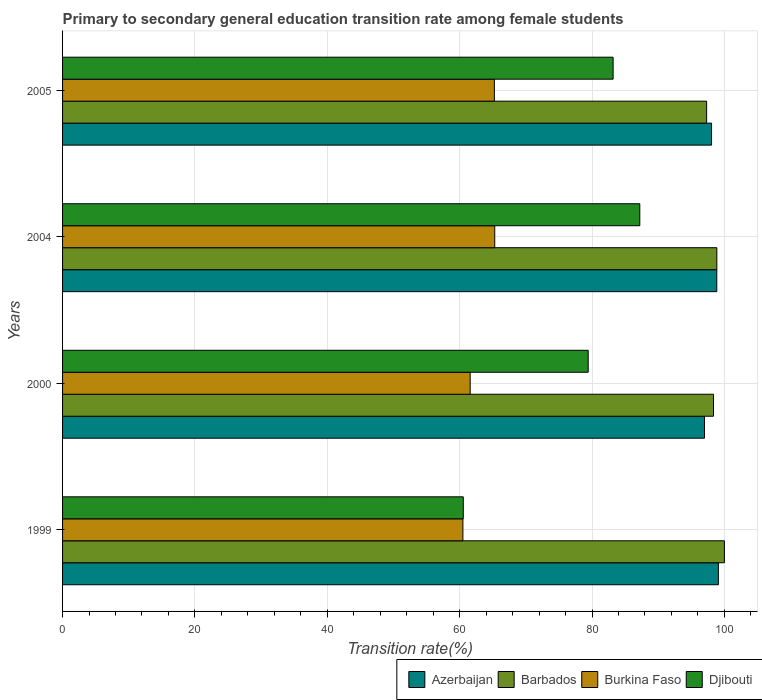How many different coloured bars are there?
Make the answer very short. 4. Are the number of bars per tick equal to the number of legend labels?
Make the answer very short. Yes. What is the transition rate in Azerbaijan in 2000?
Your answer should be compact. 96.99. Across all years, what is the maximum transition rate in Burkina Faso?
Make the answer very short. 65.3. Across all years, what is the minimum transition rate in Barbados?
Offer a terse response. 97.31. In which year was the transition rate in Azerbaijan maximum?
Make the answer very short. 1999. In which year was the transition rate in Burkina Faso minimum?
Provide a succinct answer. 1999. What is the total transition rate in Azerbaijan in the graph?
Your answer should be compact. 392.99. What is the difference between the transition rate in Barbados in 2000 and that in 2005?
Ensure brevity in your answer.  1.04. What is the difference between the transition rate in Azerbaijan in 2005 and the transition rate in Barbados in 2000?
Provide a short and direct response. -0.29. What is the average transition rate in Djibouti per year?
Keep it short and to the point. 77.59. In the year 2000, what is the difference between the transition rate in Djibouti and transition rate in Burkina Faso?
Your response must be concise. 17.83. In how many years, is the transition rate in Azerbaijan greater than 12 %?
Keep it short and to the point. 4. What is the ratio of the transition rate in Azerbaijan in 2004 to that in 2005?
Ensure brevity in your answer.  1.01. What is the difference between the highest and the second highest transition rate in Barbados?
Offer a terse response. 1.14. What is the difference between the highest and the lowest transition rate in Azerbaijan?
Provide a short and direct response. 2.1. In how many years, is the transition rate in Barbados greater than the average transition rate in Barbados taken over all years?
Keep it short and to the point. 2. Is the sum of the transition rate in Azerbaijan in 1999 and 2000 greater than the maximum transition rate in Djibouti across all years?
Your response must be concise. Yes. Is it the case that in every year, the sum of the transition rate in Barbados and transition rate in Azerbaijan is greater than the sum of transition rate in Burkina Faso and transition rate in Djibouti?
Offer a very short reply. Yes. What does the 1st bar from the top in 1999 represents?
Your answer should be very brief. Djibouti. What does the 2nd bar from the bottom in 2004 represents?
Provide a succinct answer. Barbados. Are all the bars in the graph horizontal?
Give a very brief answer. Yes. What is the difference between two consecutive major ticks on the X-axis?
Your response must be concise. 20. How are the legend labels stacked?
Provide a succinct answer. Horizontal. What is the title of the graph?
Your answer should be compact. Primary to secondary general education transition rate among female students. What is the label or title of the X-axis?
Offer a terse response. Transition rate(%). What is the Transition rate(%) of Azerbaijan in 1999?
Provide a short and direct response. 99.09. What is the Transition rate(%) of Burkina Faso in 1999?
Your answer should be very brief. 60.49. What is the Transition rate(%) of Djibouti in 1999?
Provide a succinct answer. 60.55. What is the Transition rate(%) of Azerbaijan in 2000?
Your answer should be very brief. 96.99. What is the Transition rate(%) of Barbados in 2000?
Your answer should be compact. 98.35. What is the Transition rate(%) in Burkina Faso in 2000?
Ensure brevity in your answer.  61.59. What is the Transition rate(%) of Djibouti in 2000?
Keep it short and to the point. 79.42. What is the Transition rate(%) of Azerbaijan in 2004?
Offer a very short reply. 98.85. What is the Transition rate(%) in Barbados in 2004?
Your response must be concise. 98.86. What is the Transition rate(%) in Burkina Faso in 2004?
Offer a very short reply. 65.3. What is the Transition rate(%) of Djibouti in 2004?
Provide a succinct answer. 87.22. What is the Transition rate(%) of Azerbaijan in 2005?
Ensure brevity in your answer.  98.06. What is the Transition rate(%) in Barbados in 2005?
Provide a succinct answer. 97.31. What is the Transition rate(%) of Burkina Faso in 2005?
Provide a succinct answer. 65.24. What is the Transition rate(%) of Djibouti in 2005?
Provide a succinct answer. 83.19. Across all years, what is the maximum Transition rate(%) in Azerbaijan?
Provide a short and direct response. 99.09. Across all years, what is the maximum Transition rate(%) of Burkina Faso?
Provide a short and direct response. 65.3. Across all years, what is the maximum Transition rate(%) in Djibouti?
Your response must be concise. 87.22. Across all years, what is the minimum Transition rate(%) in Azerbaijan?
Your answer should be compact. 96.99. Across all years, what is the minimum Transition rate(%) of Barbados?
Provide a short and direct response. 97.31. Across all years, what is the minimum Transition rate(%) of Burkina Faso?
Ensure brevity in your answer.  60.49. Across all years, what is the minimum Transition rate(%) of Djibouti?
Your answer should be very brief. 60.55. What is the total Transition rate(%) of Azerbaijan in the graph?
Keep it short and to the point. 392.99. What is the total Transition rate(%) in Barbados in the graph?
Offer a terse response. 394.52. What is the total Transition rate(%) of Burkina Faso in the graph?
Ensure brevity in your answer.  252.62. What is the total Transition rate(%) of Djibouti in the graph?
Make the answer very short. 310.37. What is the difference between the Transition rate(%) of Azerbaijan in 1999 and that in 2000?
Keep it short and to the point. 2.1. What is the difference between the Transition rate(%) of Barbados in 1999 and that in 2000?
Your answer should be compact. 1.65. What is the difference between the Transition rate(%) in Burkina Faso in 1999 and that in 2000?
Offer a very short reply. -1.1. What is the difference between the Transition rate(%) in Djibouti in 1999 and that in 2000?
Provide a short and direct response. -18.87. What is the difference between the Transition rate(%) in Azerbaijan in 1999 and that in 2004?
Your answer should be very brief. 0.24. What is the difference between the Transition rate(%) of Barbados in 1999 and that in 2004?
Your answer should be compact. 1.14. What is the difference between the Transition rate(%) in Burkina Faso in 1999 and that in 2004?
Provide a short and direct response. -4.81. What is the difference between the Transition rate(%) of Djibouti in 1999 and that in 2004?
Give a very brief answer. -26.67. What is the difference between the Transition rate(%) of Azerbaijan in 1999 and that in 2005?
Ensure brevity in your answer.  1.03. What is the difference between the Transition rate(%) in Barbados in 1999 and that in 2005?
Ensure brevity in your answer.  2.69. What is the difference between the Transition rate(%) of Burkina Faso in 1999 and that in 2005?
Your response must be concise. -4.75. What is the difference between the Transition rate(%) of Djibouti in 1999 and that in 2005?
Your response must be concise. -22.64. What is the difference between the Transition rate(%) of Azerbaijan in 2000 and that in 2004?
Provide a short and direct response. -1.86. What is the difference between the Transition rate(%) in Barbados in 2000 and that in 2004?
Provide a succinct answer. -0.5. What is the difference between the Transition rate(%) in Burkina Faso in 2000 and that in 2004?
Keep it short and to the point. -3.71. What is the difference between the Transition rate(%) of Djibouti in 2000 and that in 2004?
Make the answer very short. -7.8. What is the difference between the Transition rate(%) of Azerbaijan in 2000 and that in 2005?
Your response must be concise. -1.07. What is the difference between the Transition rate(%) of Barbados in 2000 and that in 2005?
Keep it short and to the point. 1.04. What is the difference between the Transition rate(%) in Burkina Faso in 2000 and that in 2005?
Provide a short and direct response. -3.66. What is the difference between the Transition rate(%) of Djibouti in 2000 and that in 2005?
Keep it short and to the point. -3.77. What is the difference between the Transition rate(%) in Azerbaijan in 2004 and that in 2005?
Provide a succinct answer. 0.79. What is the difference between the Transition rate(%) of Barbados in 2004 and that in 2005?
Offer a very short reply. 1.54. What is the difference between the Transition rate(%) in Burkina Faso in 2004 and that in 2005?
Give a very brief answer. 0.06. What is the difference between the Transition rate(%) of Djibouti in 2004 and that in 2005?
Give a very brief answer. 4.03. What is the difference between the Transition rate(%) in Azerbaijan in 1999 and the Transition rate(%) in Barbados in 2000?
Your answer should be very brief. 0.74. What is the difference between the Transition rate(%) in Azerbaijan in 1999 and the Transition rate(%) in Burkina Faso in 2000?
Offer a terse response. 37.51. What is the difference between the Transition rate(%) of Azerbaijan in 1999 and the Transition rate(%) of Djibouti in 2000?
Give a very brief answer. 19.67. What is the difference between the Transition rate(%) of Barbados in 1999 and the Transition rate(%) of Burkina Faso in 2000?
Offer a very short reply. 38.41. What is the difference between the Transition rate(%) of Barbados in 1999 and the Transition rate(%) of Djibouti in 2000?
Provide a short and direct response. 20.58. What is the difference between the Transition rate(%) in Burkina Faso in 1999 and the Transition rate(%) in Djibouti in 2000?
Ensure brevity in your answer.  -18.93. What is the difference between the Transition rate(%) in Azerbaijan in 1999 and the Transition rate(%) in Barbados in 2004?
Your answer should be compact. 0.23. What is the difference between the Transition rate(%) of Azerbaijan in 1999 and the Transition rate(%) of Burkina Faso in 2004?
Make the answer very short. 33.79. What is the difference between the Transition rate(%) of Azerbaijan in 1999 and the Transition rate(%) of Djibouti in 2004?
Provide a short and direct response. 11.88. What is the difference between the Transition rate(%) of Barbados in 1999 and the Transition rate(%) of Burkina Faso in 2004?
Provide a short and direct response. 34.7. What is the difference between the Transition rate(%) of Barbados in 1999 and the Transition rate(%) of Djibouti in 2004?
Your response must be concise. 12.78. What is the difference between the Transition rate(%) of Burkina Faso in 1999 and the Transition rate(%) of Djibouti in 2004?
Offer a very short reply. -26.73. What is the difference between the Transition rate(%) in Azerbaijan in 1999 and the Transition rate(%) in Barbados in 2005?
Offer a terse response. 1.78. What is the difference between the Transition rate(%) of Azerbaijan in 1999 and the Transition rate(%) of Burkina Faso in 2005?
Your response must be concise. 33.85. What is the difference between the Transition rate(%) in Azerbaijan in 1999 and the Transition rate(%) in Djibouti in 2005?
Keep it short and to the point. 15.9. What is the difference between the Transition rate(%) in Barbados in 1999 and the Transition rate(%) in Burkina Faso in 2005?
Your response must be concise. 34.76. What is the difference between the Transition rate(%) of Barbados in 1999 and the Transition rate(%) of Djibouti in 2005?
Make the answer very short. 16.81. What is the difference between the Transition rate(%) of Burkina Faso in 1999 and the Transition rate(%) of Djibouti in 2005?
Make the answer very short. -22.7. What is the difference between the Transition rate(%) in Azerbaijan in 2000 and the Transition rate(%) in Barbados in 2004?
Offer a terse response. -1.87. What is the difference between the Transition rate(%) in Azerbaijan in 2000 and the Transition rate(%) in Burkina Faso in 2004?
Your response must be concise. 31.69. What is the difference between the Transition rate(%) of Azerbaijan in 2000 and the Transition rate(%) of Djibouti in 2004?
Provide a short and direct response. 9.77. What is the difference between the Transition rate(%) of Barbados in 2000 and the Transition rate(%) of Burkina Faso in 2004?
Your response must be concise. 33.05. What is the difference between the Transition rate(%) in Barbados in 2000 and the Transition rate(%) in Djibouti in 2004?
Offer a terse response. 11.14. What is the difference between the Transition rate(%) in Burkina Faso in 2000 and the Transition rate(%) in Djibouti in 2004?
Provide a short and direct response. -25.63. What is the difference between the Transition rate(%) of Azerbaijan in 2000 and the Transition rate(%) of Barbados in 2005?
Your response must be concise. -0.32. What is the difference between the Transition rate(%) in Azerbaijan in 2000 and the Transition rate(%) in Burkina Faso in 2005?
Give a very brief answer. 31.75. What is the difference between the Transition rate(%) in Azerbaijan in 2000 and the Transition rate(%) in Djibouti in 2005?
Offer a terse response. 13.8. What is the difference between the Transition rate(%) of Barbados in 2000 and the Transition rate(%) of Burkina Faso in 2005?
Provide a short and direct response. 33.11. What is the difference between the Transition rate(%) in Barbados in 2000 and the Transition rate(%) in Djibouti in 2005?
Your answer should be very brief. 15.16. What is the difference between the Transition rate(%) of Burkina Faso in 2000 and the Transition rate(%) of Djibouti in 2005?
Keep it short and to the point. -21.6. What is the difference between the Transition rate(%) of Azerbaijan in 2004 and the Transition rate(%) of Barbados in 2005?
Give a very brief answer. 1.53. What is the difference between the Transition rate(%) of Azerbaijan in 2004 and the Transition rate(%) of Burkina Faso in 2005?
Provide a succinct answer. 33.61. What is the difference between the Transition rate(%) in Azerbaijan in 2004 and the Transition rate(%) in Djibouti in 2005?
Your answer should be very brief. 15.66. What is the difference between the Transition rate(%) of Barbados in 2004 and the Transition rate(%) of Burkina Faso in 2005?
Provide a short and direct response. 33.62. What is the difference between the Transition rate(%) in Barbados in 2004 and the Transition rate(%) in Djibouti in 2005?
Your response must be concise. 15.67. What is the difference between the Transition rate(%) in Burkina Faso in 2004 and the Transition rate(%) in Djibouti in 2005?
Provide a short and direct response. -17.89. What is the average Transition rate(%) of Azerbaijan per year?
Provide a short and direct response. 98.25. What is the average Transition rate(%) of Barbados per year?
Make the answer very short. 98.63. What is the average Transition rate(%) in Burkina Faso per year?
Your answer should be very brief. 63.15. What is the average Transition rate(%) in Djibouti per year?
Keep it short and to the point. 77.59. In the year 1999, what is the difference between the Transition rate(%) in Azerbaijan and Transition rate(%) in Barbados?
Your response must be concise. -0.91. In the year 1999, what is the difference between the Transition rate(%) of Azerbaijan and Transition rate(%) of Burkina Faso?
Your response must be concise. 38.6. In the year 1999, what is the difference between the Transition rate(%) of Azerbaijan and Transition rate(%) of Djibouti?
Give a very brief answer. 38.55. In the year 1999, what is the difference between the Transition rate(%) in Barbados and Transition rate(%) in Burkina Faso?
Ensure brevity in your answer.  39.51. In the year 1999, what is the difference between the Transition rate(%) in Barbados and Transition rate(%) in Djibouti?
Your answer should be compact. 39.45. In the year 1999, what is the difference between the Transition rate(%) of Burkina Faso and Transition rate(%) of Djibouti?
Ensure brevity in your answer.  -0.05. In the year 2000, what is the difference between the Transition rate(%) in Azerbaijan and Transition rate(%) in Barbados?
Ensure brevity in your answer.  -1.36. In the year 2000, what is the difference between the Transition rate(%) of Azerbaijan and Transition rate(%) of Burkina Faso?
Keep it short and to the point. 35.4. In the year 2000, what is the difference between the Transition rate(%) of Azerbaijan and Transition rate(%) of Djibouti?
Provide a short and direct response. 17.57. In the year 2000, what is the difference between the Transition rate(%) in Barbados and Transition rate(%) in Burkina Faso?
Give a very brief answer. 36.77. In the year 2000, what is the difference between the Transition rate(%) of Barbados and Transition rate(%) of Djibouti?
Your answer should be compact. 18.93. In the year 2000, what is the difference between the Transition rate(%) in Burkina Faso and Transition rate(%) in Djibouti?
Keep it short and to the point. -17.83. In the year 2004, what is the difference between the Transition rate(%) of Azerbaijan and Transition rate(%) of Barbados?
Your answer should be compact. -0.01. In the year 2004, what is the difference between the Transition rate(%) of Azerbaijan and Transition rate(%) of Burkina Faso?
Your answer should be compact. 33.55. In the year 2004, what is the difference between the Transition rate(%) in Azerbaijan and Transition rate(%) in Djibouti?
Your answer should be very brief. 11.63. In the year 2004, what is the difference between the Transition rate(%) of Barbados and Transition rate(%) of Burkina Faso?
Your answer should be very brief. 33.56. In the year 2004, what is the difference between the Transition rate(%) of Barbados and Transition rate(%) of Djibouti?
Your response must be concise. 11.64. In the year 2004, what is the difference between the Transition rate(%) in Burkina Faso and Transition rate(%) in Djibouti?
Ensure brevity in your answer.  -21.92. In the year 2005, what is the difference between the Transition rate(%) in Azerbaijan and Transition rate(%) in Barbados?
Make the answer very short. 0.75. In the year 2005, what is the difference between the Transition rate(%) of Azerbaijan and Transition rate(%) of Burkina Faso?
Ensure brevity in your answer.  32.82. In the year 2005, what is the difference between the Transition rate(%) of Azerbaijan and Transition rate(%) of Djibouti?
Provide a succinct answer. 14.87. In the year 2005, what is the difference between the Transition rate(%) of Barbados and Transition rate(%) of Burkina Faso?
Keep it short and to the point. 32.07. In the year 2005, what is the difference between the Transition rate(%) in Barbados and Transition rate(%) in Djibouti?
Provide a succinct answer. 14.13. In the year 2005, what is the difference between the Transition rate(%) of Burkina Faso and Transition rate(%) of Djibouti?
Make the answer very short. -17.95. What is the ratio of the Transition rate(%) in Azerbaijan in 1999 to that in 2000?
Provide a succinct answer. 1.02. What is the ratio of the Transition rate(%) of Barbados in 1999 to that in 2000?
Give a very brief answer. 1.02. What is the ratio of the Transition rate(%) of Burkina Faso in 1999 to that in 2000?
Your answer should be compact. 0.98. What is the ratio of the Transition rate(%) of Djibouti in 1999 to that in 2000?
Provide a short and direct response. 0.76. What is the ratio of the Transition rate(%) of Barbados in 1999 to that in 2004?
Offer a very short reply. 1.01. What is the ratio of the Transition rate(%) of Burkina Faso in 1999 to that in 2004?
Make the answer very short. 0.93. What is the ratio of the Transition rate(%) of Djibouti in 1999 to that in 2004?
Your response must be concise. 0.69. What is the ratio of the Transition rate(%) of Azerbaijan in 1999 to that in 2005?
Provide a succinct answer. 1.01. What is the ratio of the Transition rate(%) of Barbados in 1999 to that in 2005?
Offer a terse response. 1.03. What is the ratio of the Transition rate(%) in Burkina Faso in 1999 to that in 2005?
Offer a terse response. 0.93. What is the ratio of the Transition rate(%) in Djibouti in 1999 to that in 2005?
Ensure brevity in your answer.  0.73. What is the ratio of the Transition rate(%) of Azerbaijan in 2000 to that in 2004?
Your answer should be compact. 0.98. What is the ratio of the Transition rate(%) of Burkina Faso in 2000 to that in 2004?
Provide a succinct answer. 0.94. What is the ratio of the Transition rate(%) of Djibouti in 2000 to that in 2004?
Give a very brief answer. 0.91. What is the ratio of the Transition rate(%) of Barbados in 2000 to that in 2005?
Ensure brevity in your answer.  1.01. What is the ratio of the Transition rate(%) in Burkina Faso in 2000 to that in 2005?
Ensure brevity in your answer.  0.94. What is the ratio of the Transition rate(%) in Djibouti in 2000 to that in 2005?
Ensure brevity in your answer.  0.95. What is the ratio of the Transition rate(%) in Azerbaijan in 2004 to that in 2005?
Keep it short and to the point. 1.01. What is the ratio of the Transition rate(%) of Barbados in 2004 to that in 2005?
Your answer should be compact. 1.02. What is the ratio of the Transition rate(%) in Djibouti in 2004 to that in 2005?
Your response must be concise. 1.05. What is the difference between the highest and the second highest Transition rate(%) of Azerbaijan?
Offer a very short reply. 0.24. What is the difference between the highest and the second highest Transition rate(%) in Barbados?
Give a very brief answer. 1.14. What is the difference between the highest and the second highest Transition rate(%) in Burkina Faso?
Provide a succinct answer. 0.06. What is the difference between the highest and the second highest Transition rate(%) in Djibouti?
Provide a succinct answer. 4.03. What is the difference between the highest and the lowest Transition rate(%) in Azerbaijan?
Offer a terse response. 2.1. What is the difference between the highest and the lowest Transition rate(%) of Barbados?
Offer a very short reply. 2.69. What is the difference between the highest and the lowest Transition rate(%) in Burkina Faso?
Provide a succinct answer. 4.81. What is the difference between the highest and the lowest Transition rate(%) of Djibouti?
Your answer should be compact. 26.67. 